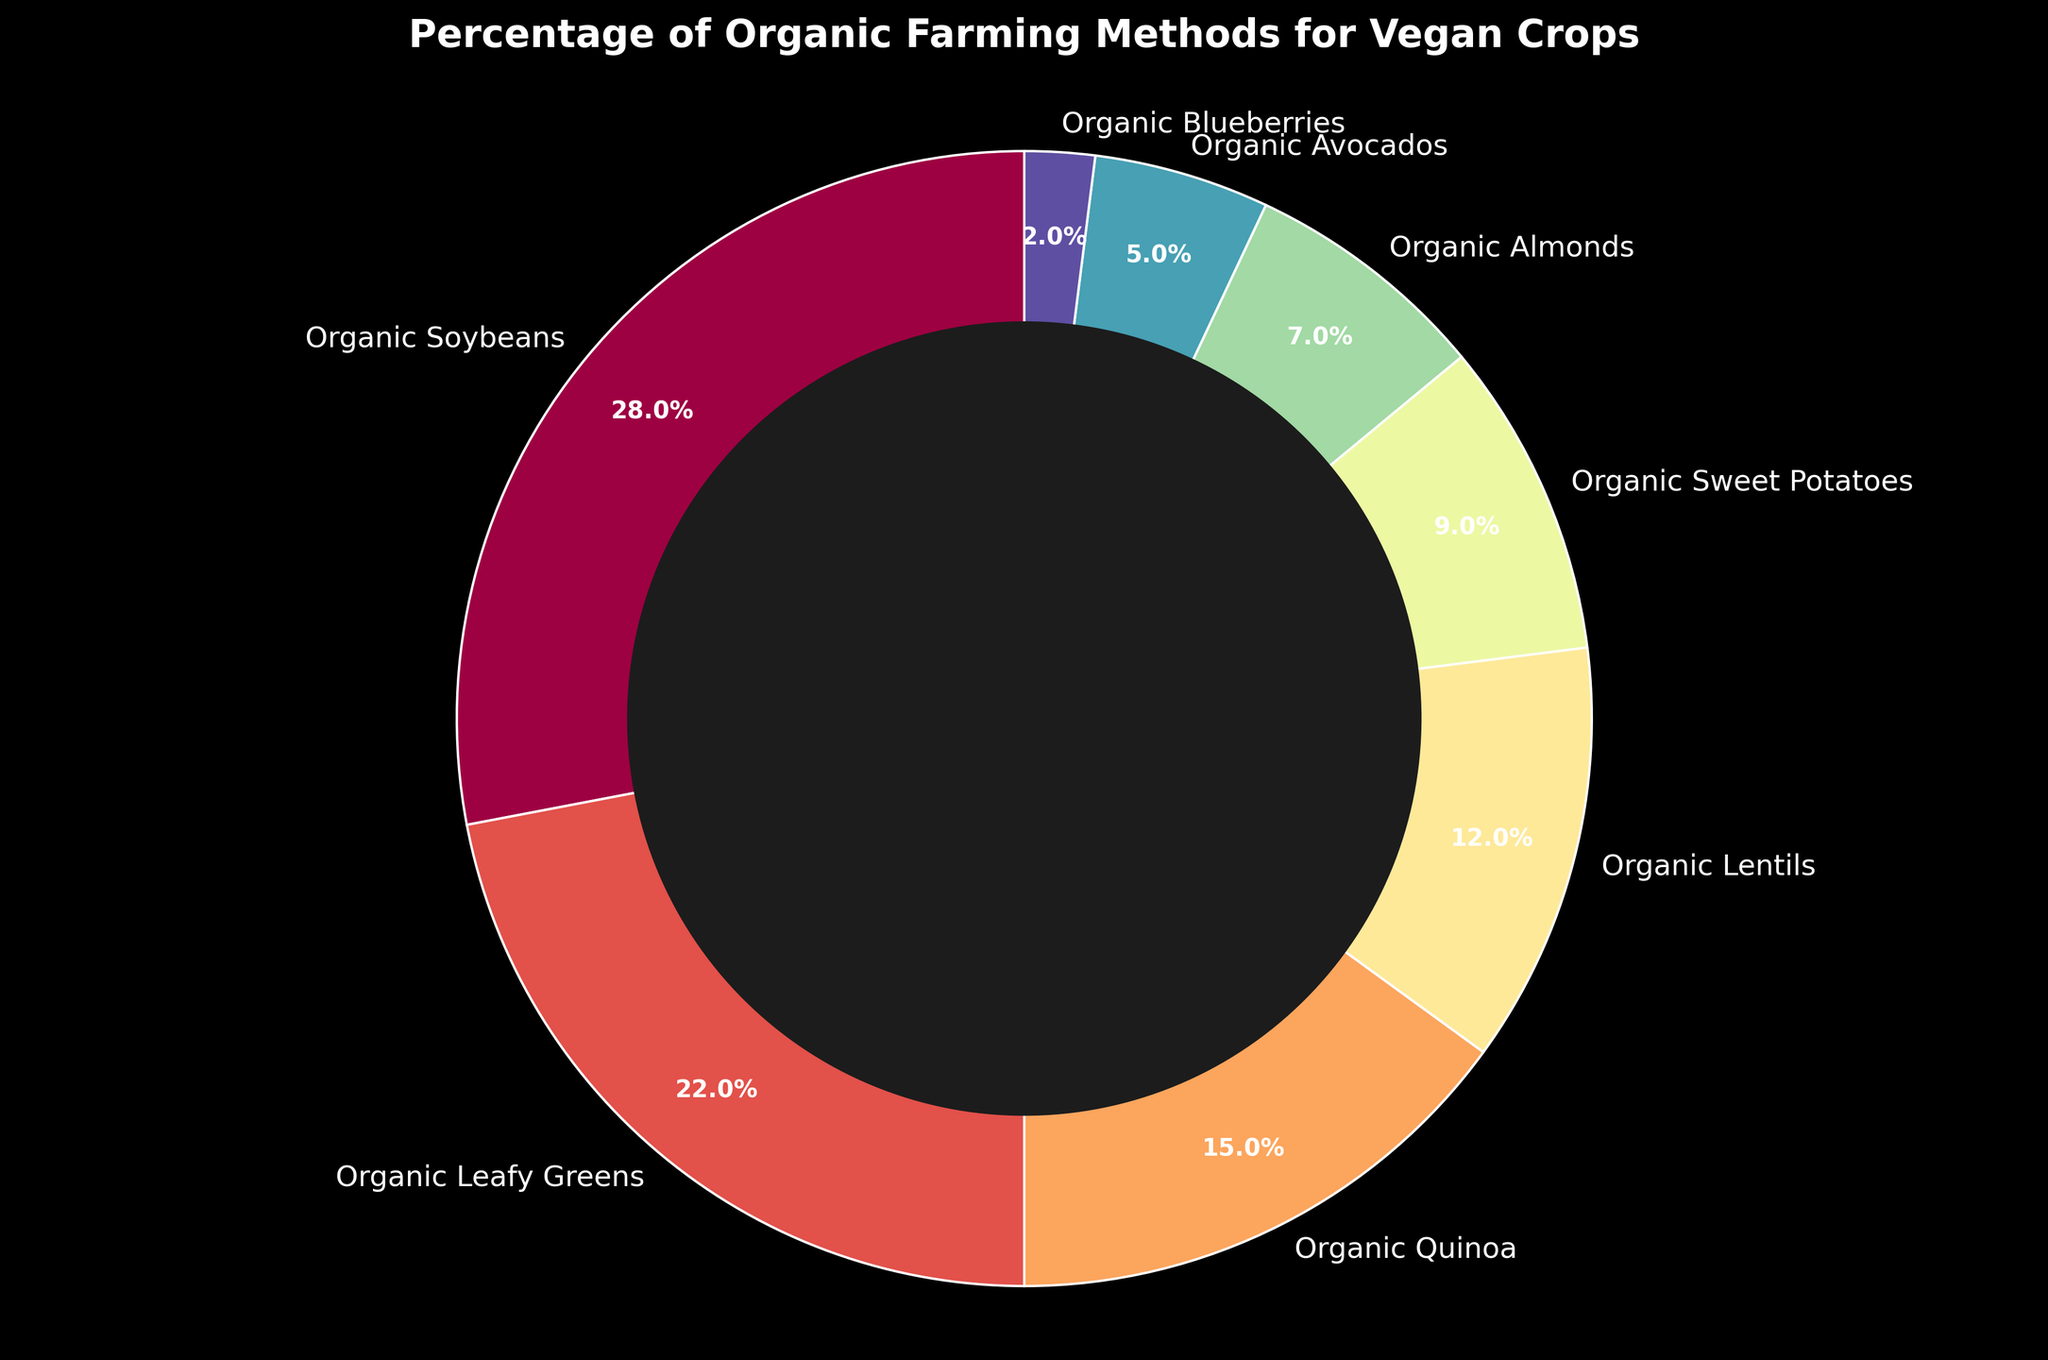What percentage of the farming methods are used for Organic Almonds and Organic Avocados combined? Add the percentage of Organic Almonds (7%) and Organic Avocados (5%) together: 7% + 5% = 12%.
Answer: 12% Which crop has the highest percentage of organic farming methods? Identify the crop with the largest percentage in the pie chart, which is Organic Soybeans at 28%.
Answer: Organic Soybeans What percentage is used for crops other than Organic Soybeans? Subtract the percentage of Organic Soybeans (28%) from 100%: 100% - 28% = 72%.
Answer: 72% Is the percentage of organic farming methods for Organic Quinoa greater than that for Organic Lentils? Compare the percentages: Organic Quinoa is at 15%, and Organic Lentils are at 12%. Yes, 15% is greater than 12%.
Answer: Yes What is the difference in percentage between Organic Leafy Greens and Organic Blueberries? Subtract the percentage of Organic Blueberries (2%) from Organic Leafy Greens (22%): 22% - 2% = 20%.
Answer: 20% Which crop represents the smallest percentage in the pie chart? Identify the smallest segment in the pie chart, which represents Organic Blueberries at 2%.
Answer: Organic Blueberries What is the combined percentage of Organic Leafy Greens, Organic Quinoa, and Organic Lentils? Add the percentages: Organic Leafy Greens (22%) + Organic Quinoa (15%) + Organic Lentils (12%) = 49%.
Answer: 49% Are the percentages for Organic Sweet Potatoes and Organic Avocados equal to that for Organic Lentils? Add the percentages of Organic Sweet Potatoes (9%) and Organic Avocados (5%) and compare to Organic Lentils (12%): 9% + 5% = 14%, which is not equal to 12%.
Answer: No What is the total percentage for Organic Leafy Greens and Organic Sweet Potatoes? Add the percentages: Organic Leafy Greens (22%) + Organic Sweet Potatoes (9%) = 31%.
Answer: 31% Is the combined percentage of the two smallest categories greater than Organic Almonds? Add the percentages of Organic Blueberries (2%) and Organic Avocados (5%) and compare with Organic Almonds (7%): 2% + 5% = 7%, which is equal to 7%.
Answer: Yes 